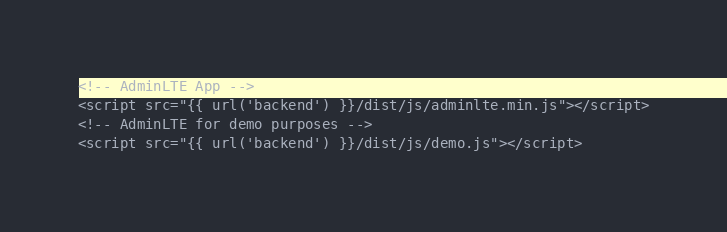<code> <loc_0><loc_0><loc_500><loc_500><_PHP_><!-- AdminLTE App -->
<script src="{{ url('backend') }}/dist/js/adminlte.min.js"></script>
<!-- AdminLTE for demo purposes -->
<script src="{{ url('backend') }}/dist/js/demo.js"></script></code> 